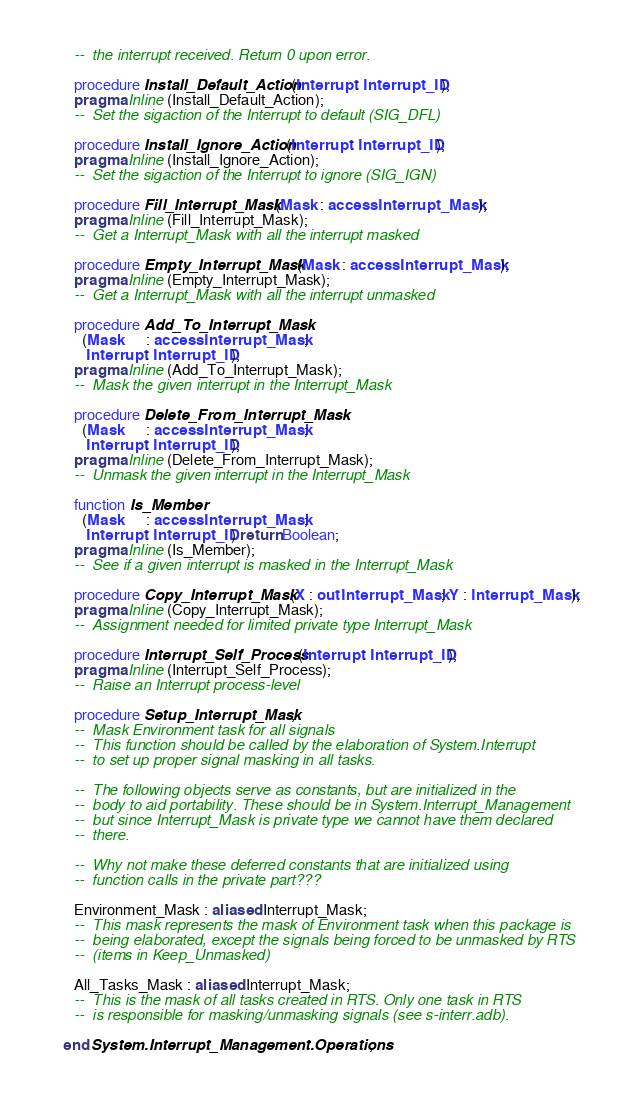<code> <loc_0><loc_0><loc_500><loc_500><_Ada_>   --  the interrupt received. Return 0 upon error.

   procedure Install_Default_Action (Interrupt : Interrupt_ID);
   pragma Inline (Install_Default_Action);
   --  Set the sigaction of the Interrupt to default (SIG_DFL)

   procedure Install_Ignore_Action (Interrupt : Interrupt_ID);
   pragma Inline (Install_Ignore_Action);
   --  Set the sigaction of the Interrupt to ignore (SIG_IGN)

   procedure Fill_Interrupt_Mask (Mask : access Interrupt_Mask);
   pragma Inline (Fill_Interrupt_Mask);
   --  Get a Interrupt_Mask with all the interrupt masked

   procedure Empty_Interrupt_Mask (Mask : access Interrupt_Mask);
   pragma Inline (Empty_Interrupt_Mask);
   --  Get a Interrupt_Mask with all the interrupt unmasked

   procedure Add_To_Interrupt_Mask
     (Mask      : access Interrupt_Mask;
      Interrupt : Interrupt_ID);
   pragma Inline (Add_To_Interrupt_Mask);
   --  Mask the given interrupt in the Interrupt_Mask

   procedure Delete_From_Interrupt_Mask
     (Mask      : access Interrupt_Mask;
      Interrupt : Interrupt_ID);
   pragma Inline (Delete_From_Interrupt_Mask);
   --  Unmask the given interrupt in the Interrupt_Mask

   function Is_Member
     (Mask      : access Interrupt_Mask;
      Interrupt : Interrupt_ID) return Boolean;
   pragma Inline (Is_Member);
   --  See if a given interrupt is masked in the Interrupt_Mask

   procedure Copy_Interrupt_Mask (X : out Interrupt_Mask; Y : Interrupt_Mask);
   pragma Inline (Copy_Interrupt_Mask);
   --  Assignment needed for limited private type Interrupt_Mask

   procedure Interrupt_Self_Process (Interrupt : Interrupt_ID);
   pragma Inline (Interrupt_Self_Process);
   --  Raise an Interrupt process-level

   procedure Setup_Interrupt_Mask;
   --  Mask Environment task for all signals
   --  This function should be called by the elaboration of System.Interrupt
   --  to set up proper signal masking in all tasks.

   --  The following objects serve as constants, but are initialized in the
   --  body to aid portability. These should be in System.Interrupt_Management
   --  but since Interrupt_Mask is private type we cannot have them declared
   --  there.

   --  Why not make these deferred constants that are initialized using
   --  function calls in the private part???

   Environment_Mask : aliased Interrupt_Mask;
   --  This mask represents the mask of Environment task when this package is
   --  being elaborated, except the signals being forced to be unmasked by RTS
   --  (items in Keep_Unmasked)

   All_Tasks_Mask : aliased Interrupt_Mask;
   --  This is the mask of all tasks created in RTS. Only one task in RTS
   --  is responsible for masking/unmasking signals (see s-interr.adb).

end System.Interrupt_Management.Operations;
</code> 